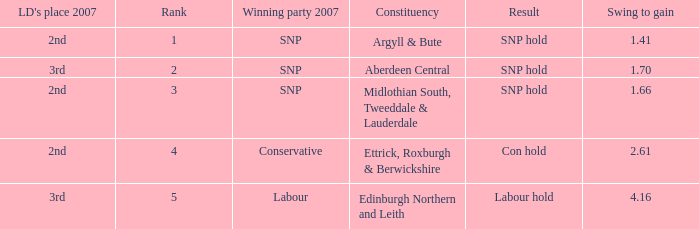What is the constituency when the rank is less than 5 and the result is con hold? Ettrick, Roxburgh & Berwickshire. 